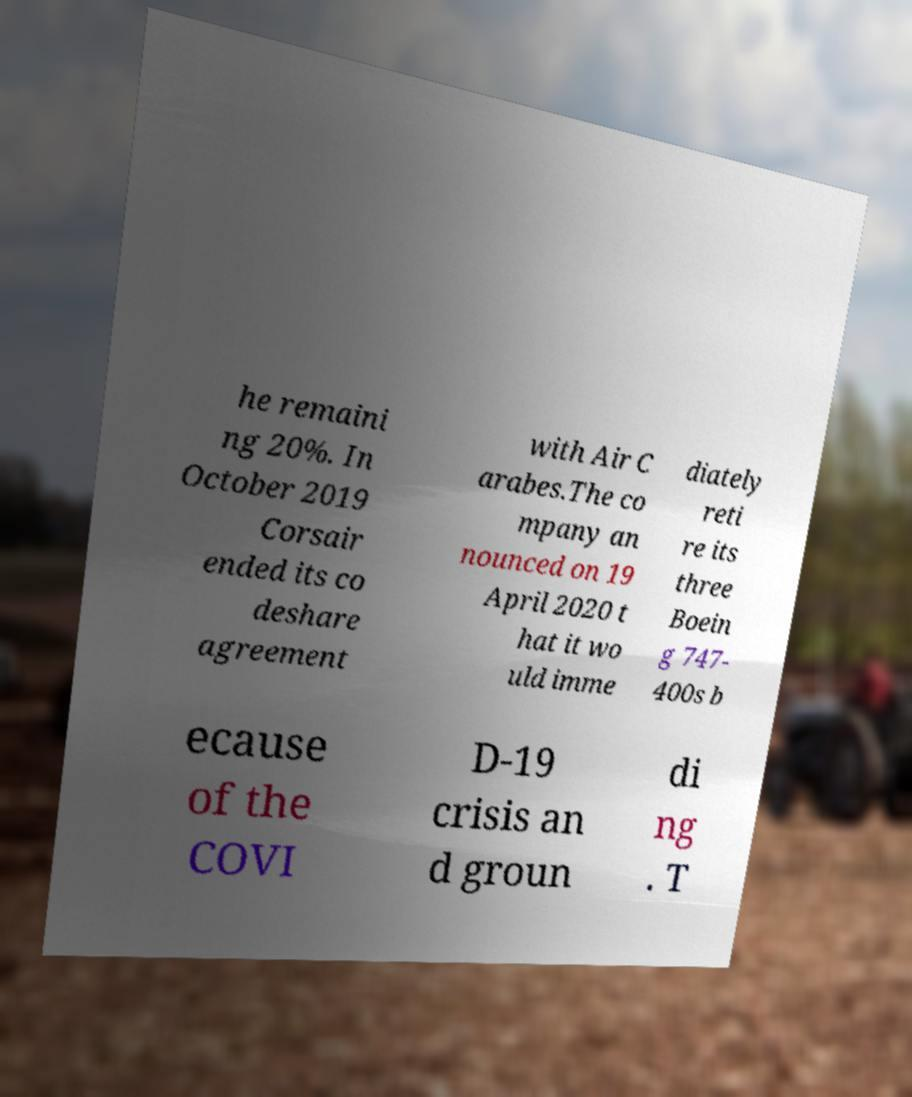Could you extract and type out the text from this image? he remaini ng 20%. In October 2019 Corsair ended its co deshare agreement with Air C arabes.The co mpany an nounced on 19 April 2020 t hat it wo uld imme diately reti re its three Boein g 747- 400s b ecause of the COVI D-19 crisis an d groun di ng . T 